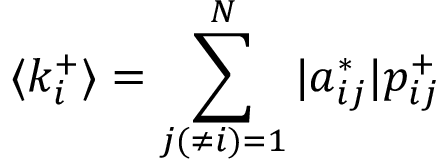Convert formula to latex. <formula><loc_0><loc_0><loc_500><loc_500>\langle k _ { i } ^ { + } \rangle = \sum _ { j ( \neq i ) = 1 } ^ { N } | a _ { i j } ^ { * } | p _ { i j } ^ { + }</formula> 